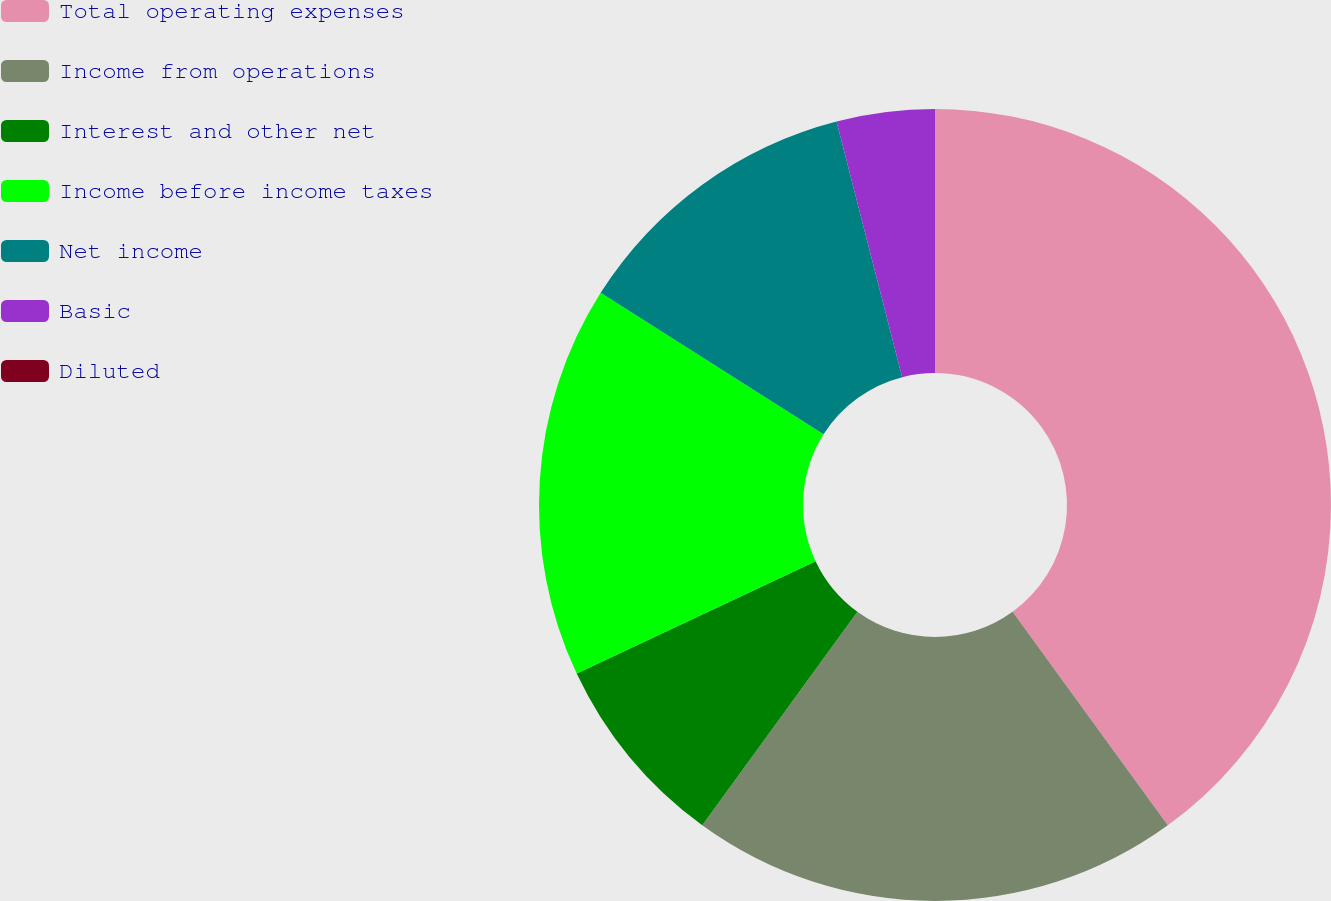<chart> <loc_0><loc_0><loc_500><loc_500><pie_chart><fcel>Total operating expenses<fcel>Income from operations<fcel>Interest and other net<fcel>Income before income taxes<fcel>Net income<fcel>Basic<fcel>Diluted<nl><fcel>40.0%<fcel>20.0%<fcel>8.0%<fcel>16.0%<fcel>12.0%<fcel>4.0%<fcel>0.0%<nl></chart> 